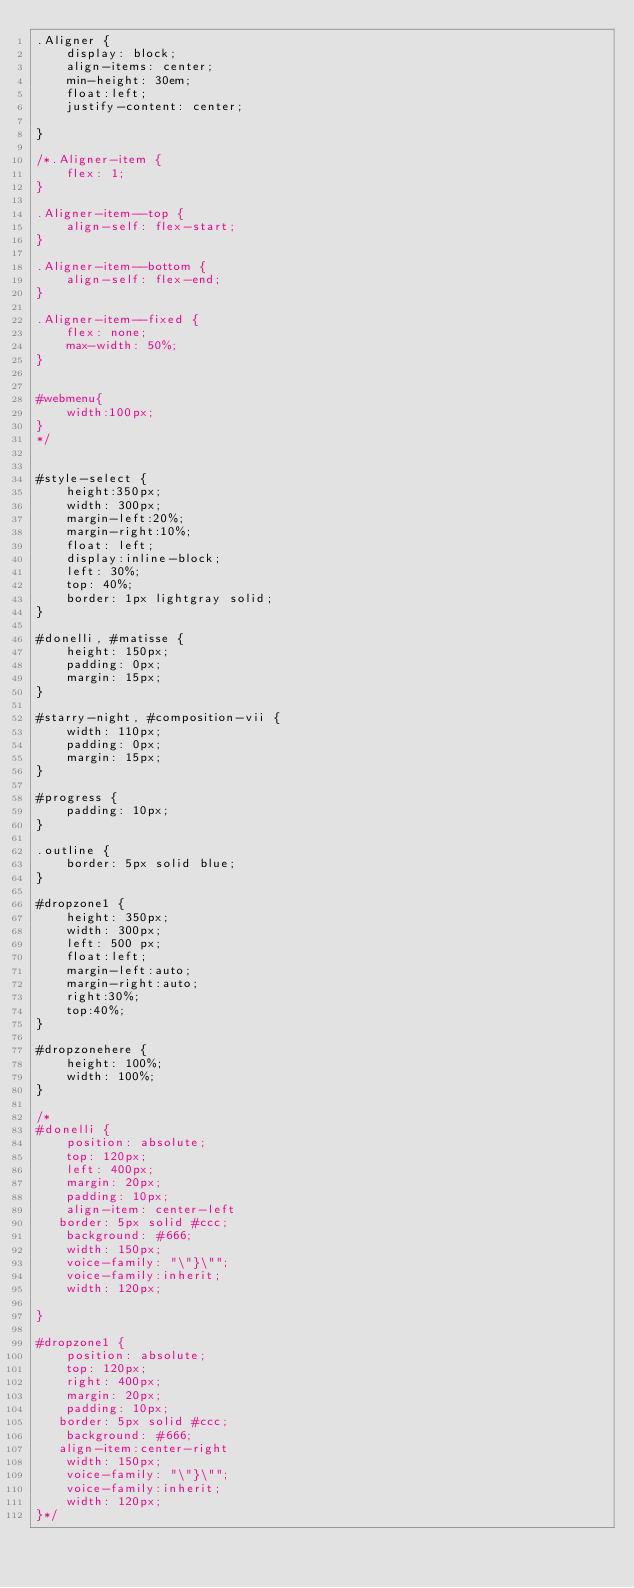Convert code to text. <code><loc_0><loc_0><loc_500><loc_500><_CSS_>.Aligner {
    display: block;
    align-items: center;
    min-height: 30em;
    float:left;
    justify-content: center;
    
}

/*.Aligner-item {
    flex: 1;
}

.Aligner-item--top {
    align-self: flex-start;
}

.Aligner-item--bottom {
    align-self: flex-end;
}

.Aligner-item--fixed {
    flex: none;
    max-width: 50%;
}


#webmenu{
    width:100px;
}
*/


#style-select {
    height:350px;
    width: 300px;
    margin-left:20%;
    margin-right:10%;
    float: left;
    display:inline-block;
    left: 30%;
    top: 40%;
	border: 1px lightgray solid;
}

#donelli, #matisse {
	height: 150px;
	padding: 0px;
	margin: 15px;
}

#starry-night, #composition-vii {
	width: 110px;
	padding: 0px;
	margin: 15px;
}

#progress {
	padding: 10px;
}

.outline {
	border: 5px solid blue;
}

#dropzone1 {
    height: 350px;
    width: 300px;
    left: 500 px;
    float:left;
    margin-left:auto;
    margin-right:auto;
    right:30%;
    top:40%;
}

#dropzonehere {
	height: 100%;
	width: 100%;
}

/*
#donelli {
    position: absolute;
    top: 120px;
    left: 400px;
    margin: 20px;
    padding: 10px;
    align-item: center-left
   border: 5px solid #ccc;
    background: #666;
    width: 150px;
    voice-family: "\"}\"";
    voice-family:inherit;
    width: 120px;
    
}

#dropzone1 {
    position: absolute;
    top: 120px;
    right: 400px;
    margin: 20px;
    padding: 10px;
   border: 5px solid #ccc;
    background: #666;
   align-item:center-right
    width: 150px;
    voice-family: "\"}\"";
    voice-family:inherit;
    width: 120px;
}*/
</code> 